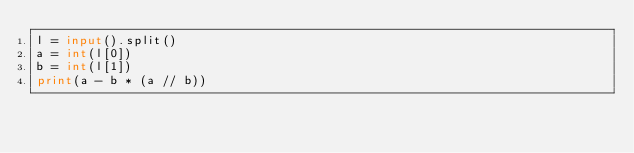<code> <loc_0><loc_0><loc_500><loc_500><_Python_>l = input().split()
a = int(l[0])
b = int(l[1])
print(a - b * (a // b))</code> 